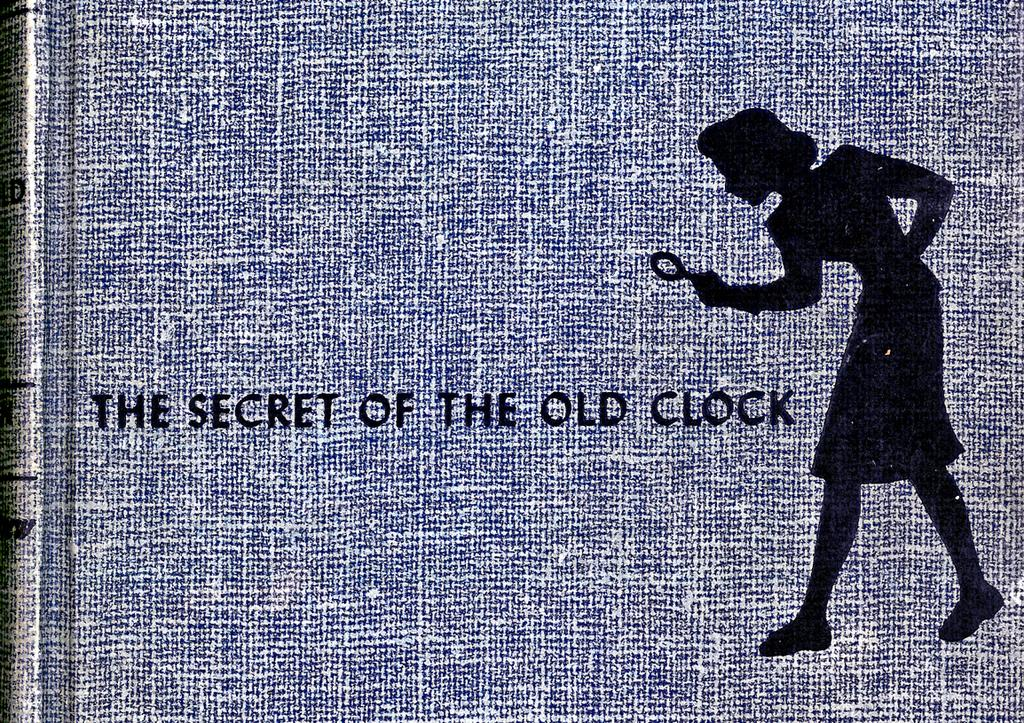What color is the main object in the image? The main object in the image is blue. What is depicted on the blue object? There is a drawing on the blue object. Are there any words or letters on the blue object? Yes, there is writing on the blue object. How much glue is needed to stick the blue object to the wall? There is no mention of glue or any intention to stick the blue object to the wall in the image or the provided facts. 